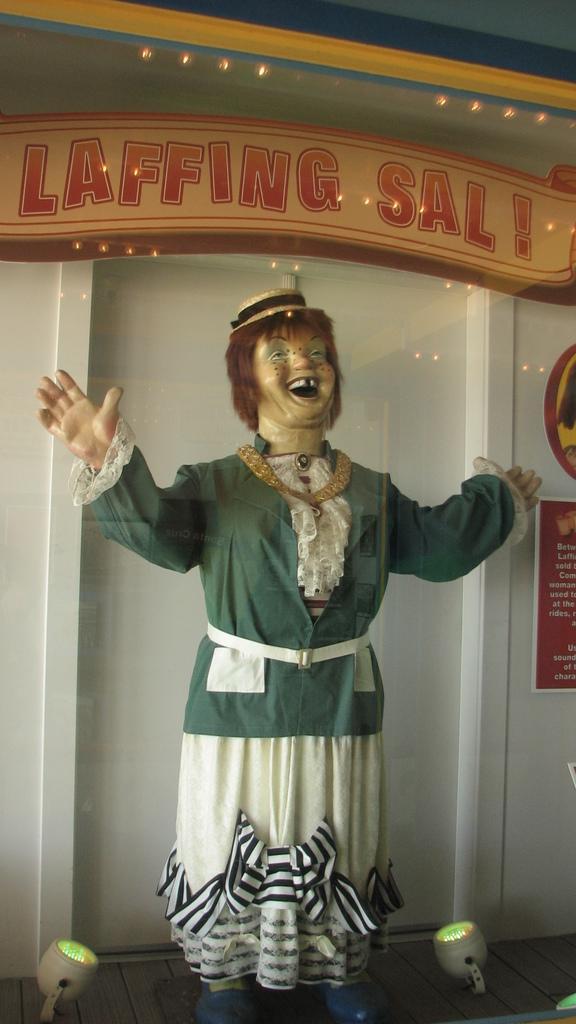Can you describe this image briefly? In this image we can see a doll wearing green coat and a cap is standing on the floor. Two light bulbs are placed beside the doll. In the background we can see a sign board saying Laffing Sal. 